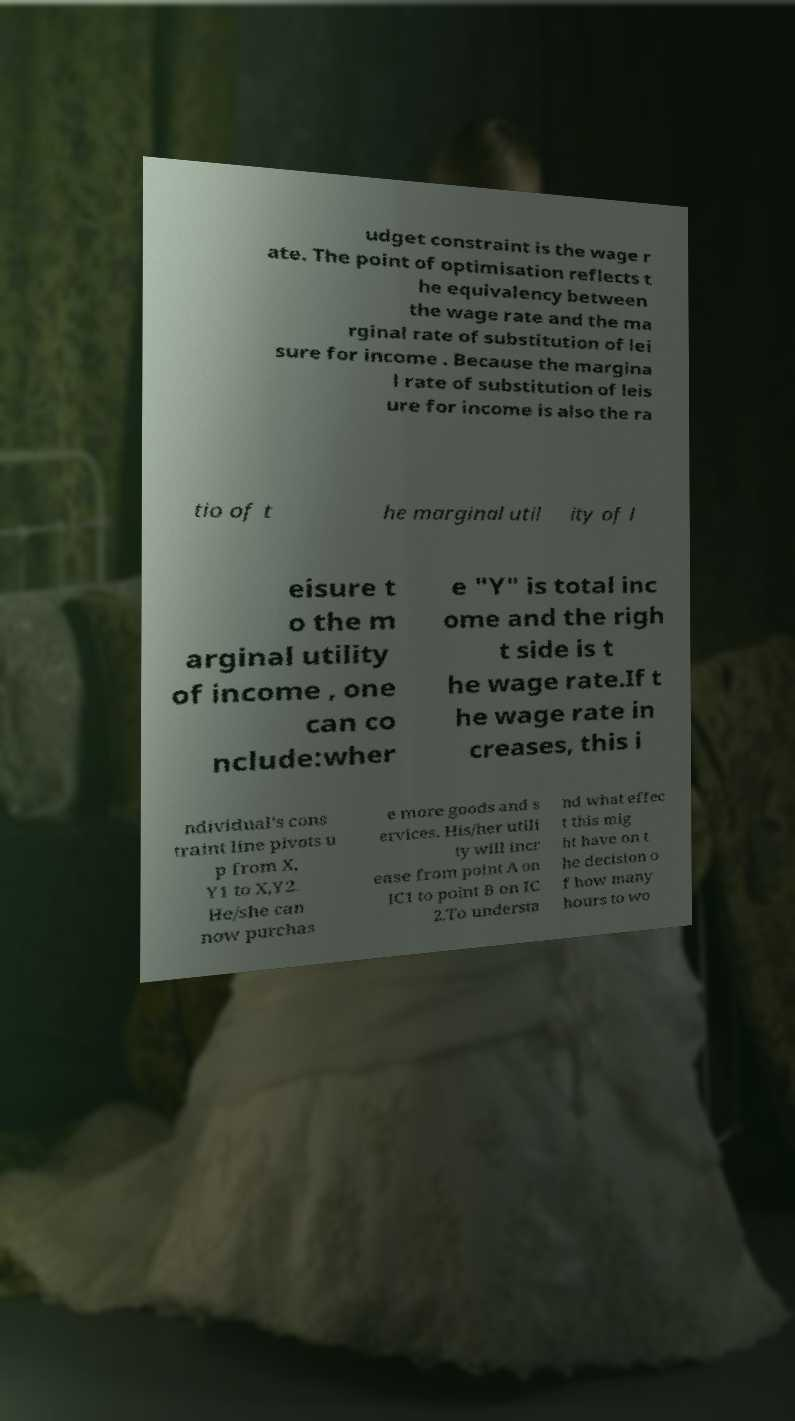Can you read and provide the text displayed in the image?This photo seems to have some interesting text. Can you extract and type it out for me? udget constraint is the wage r ate. The point of optimisation reflects t he equivalency between the wage rate and the ma rginal rate of substitution of lei sure for income . Because the margina l rate of substitution of leis ure for income is also the ra tio of t he marginal util ity of l eisure t o the m arginal utility of income , one can co nclude:wher e "Y" is total inc ome and the righ t side is t he wage rate.If t he wage rate in creases, this i ndividual's cons traint line pivots u p from X, Y1 to X,Y2. He/she can now purchas e more goods and s ervices. His/her utili ty will incr ease from point A on IC1 to point B on IC 2.To understa nd what effec t this mig ht have on t he decision o f how many hours to wo 